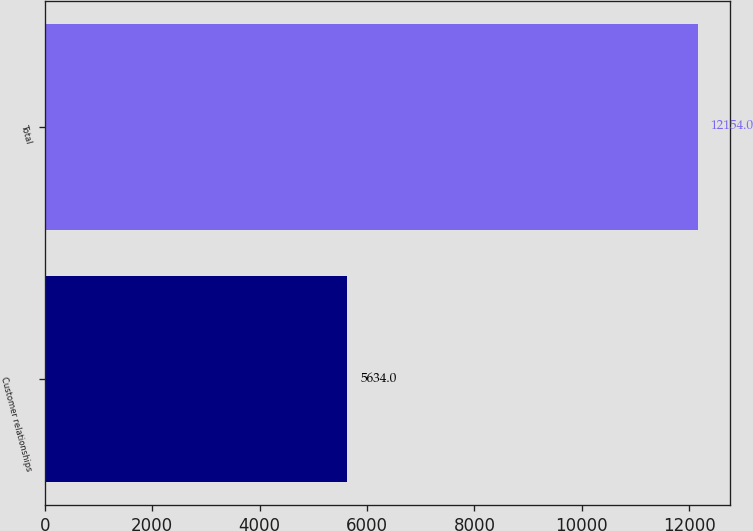Convert chart. <chart><loc_0><loc_0><loc_500><loc_500><bar_chart><fcel>Customer relationships<fcel>Total<nl><fcel>5634<fcel>12154<nl></chart> 